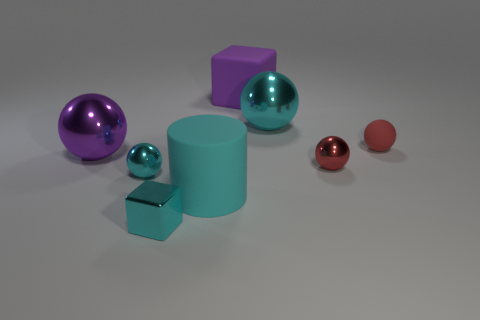What material is the cylinder that is the same color as the small metallic cube?
Make the answer very short. Rubber. What size is the purple ball that is made of the same material as the small cyan cube?
Your answer should be very brief. Large. How many matte things are large purple things or spheres?
Give a very brief answer. 2. The purple ball has what size?
Keep it short and to the point. Large. Is the red shiny object the same size as the cyan rubber cylinder?
Your answer should be compact. No. What is the material of the tiny sphere behind the purple sphere?
Your response must be concise. Rubber. What material is the other red thing that is the same shape as the tiny red shiny object?
Your answer should be compact. Rubber. Is there a block that is behind the red sphere that is to the left of the small rubber object?
Provide a short and direct response. Yes. Is the shape of the big cyan metallic object the same as the red matte thing?
Offer a very short reply. Yes. What shape is the big object that is made of the same material as the purple block?
Provide a succinct answer. Cylinder. 